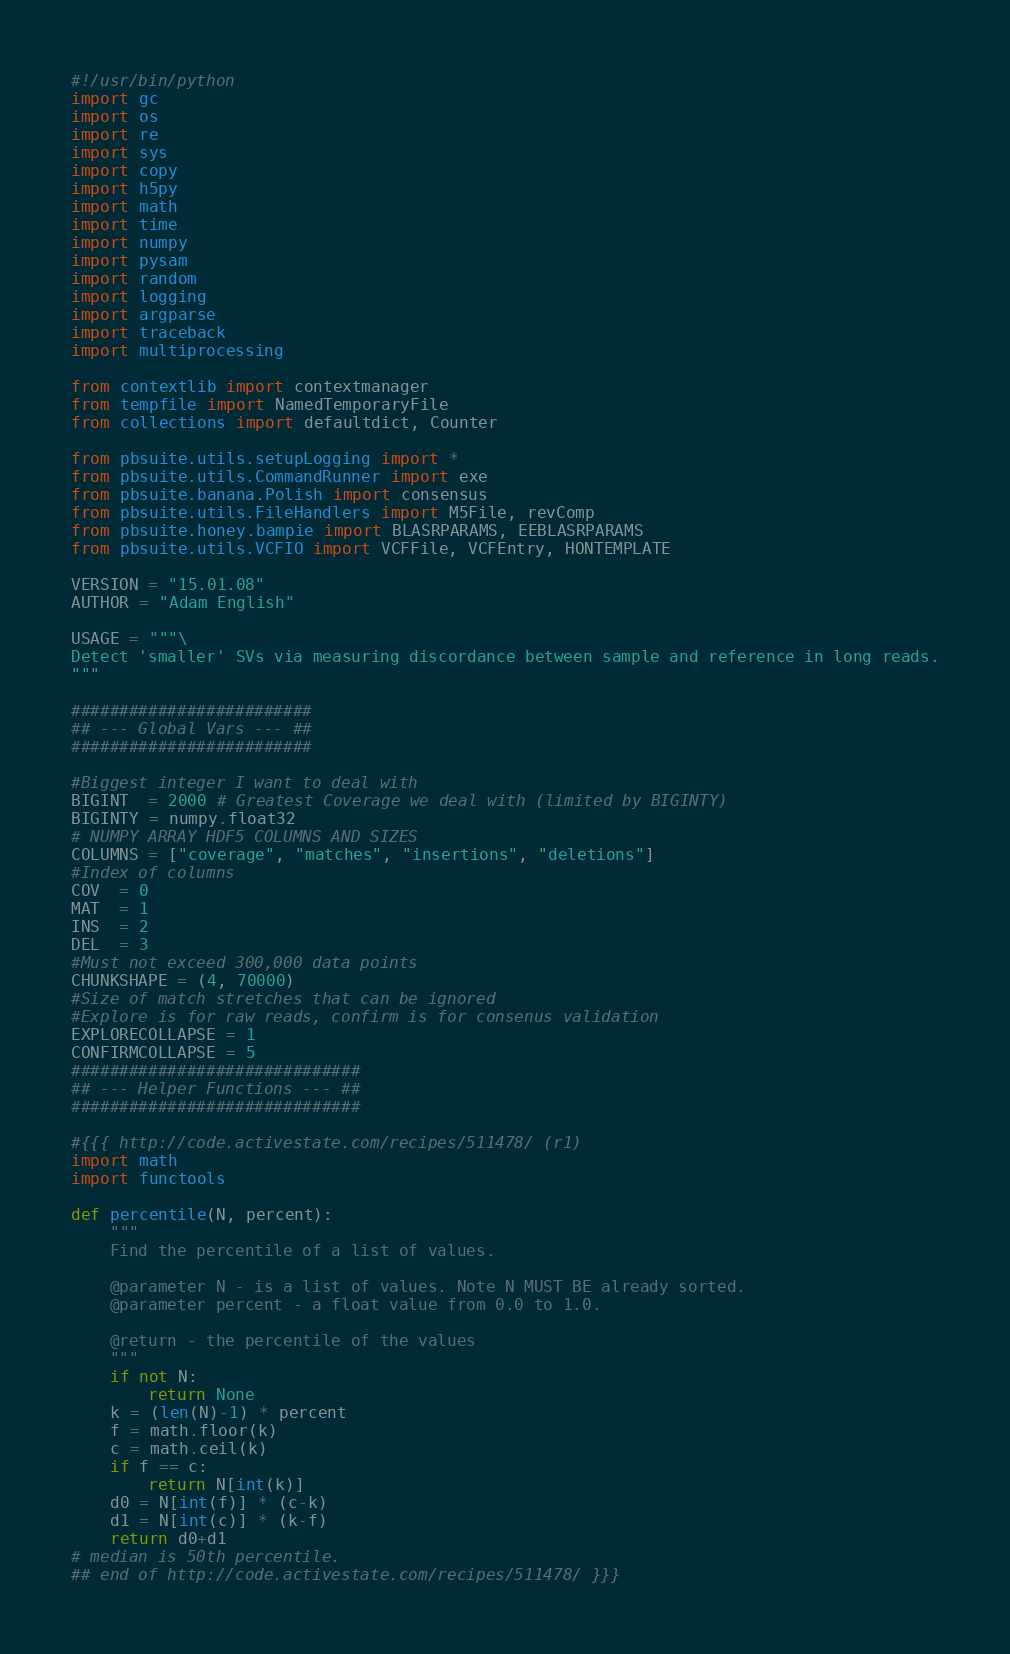Convert code to text. <code><loc_0><loc_0><loc_500><loc_500><_Python_>#!/usr/bin/python
import gc
import os
import re
import sys
import copy
import h5py
import math
import time
import numpy
import pysam
import random
import logging
import argparse 
import traceback
import multiprocessing

from contextlib import contextmanager
from tempfile import NamedTemporaryFile
from collections import defaultdict, Counter

from pbsuite.utils.setupLogging import *
from pbsuite.utils.CommandRunner import exe
from pbsuite.banana.Polish import consensus
from pbsuite.utils.FileHandlers import M5File, revComp
from pbsuite.honey.bampie import BLASRPARAMS, EEBLASRPARAMS
from pbsuite.utils.VCFIO import VCFFile, VCFEntry, HONTEMPLATE

VERSION = "15.01.08"
AUTHOR = "Adam English"

USAGE = """\
Detect 'smaller' SVs via measuring discordance between sample and reference in long reads.
"""

#########################
## --- Global Vars --- ##
#########################

#Biggest integer I want to deal with
BIGINT  = 2000 # Greatest Coverage we deal with (limited by BIGINTY)
BIGINTY = numpy.float32
# NUMPY ARRAY HDF5 COLUMNS AND SIZES
COLUMNS = ["coverage", "matches", "insertions", "deletions"]
#Index of columns
COV  = 0
MAT  = 1
INS  = 2  
DEL  = 3  
#Must not exceed 300,000 data points
CHUNKSHAPE = (4, 70000)
#Size of match stretches that can be ignored
#Explore is for raw reads, confirm is for consenus validation
EXPLORECOLLAPSE = 1
CONFIRMCOLLAPSE = 5
##############################
## --- Helper Functions --- ##
##############################

#{{{ http://code.activestate.com/recipes/511478/ (r1)
import math
import functools

def percentile(N, percent):
    """
    Find the percentile of a list of values.

    @parameter N - is a list of values. Note N MUST BE already sorted.
    @parameter percent - a float value from 0.0 to 1.0.

    @return - the percentile of the values
    """
    if not N:
        return None
    k = (len(N)-1) * percent
    f = math.floor(k)
    c = math.ceil(k)
    if f == c:
        return N[int(k)]
    d0 = N[int(f)] * (c-k)
    d1 = N[int(c)] * (k-f)
    return d0+d1
# median is 50th percentile.
## end of http://code.activestate.com/recipes/511478/ }}}

</code> 